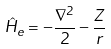<formula> <loc_0><loc_0><loc_500><loc_500>\hat { H } _ { e } = - \frac { \nabla ^ { 2 } } { 2 } - \frac { Z } { r }</formula> 